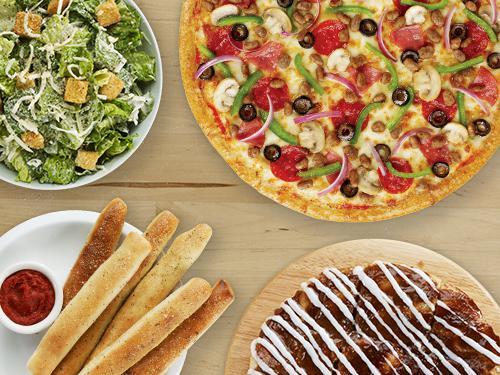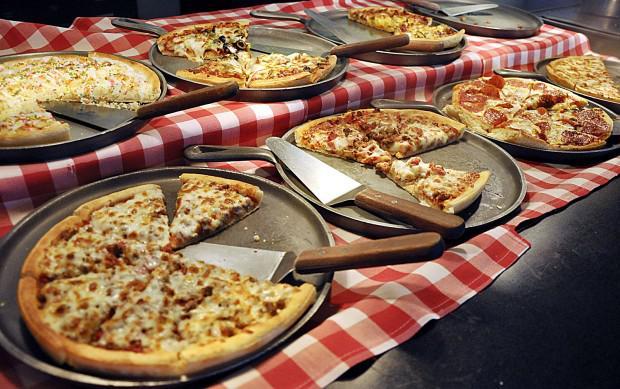The first image is the image on the left, the second image is the image on the right. Considering the images on both sides, is "There are no cut pizzas in the left image." valid? Answer yes or no. Yes. The first image is the image on the left, the second image is the image on the right. For the images displayed, is the sentence "People stand along a buffet in one of the images." factually correct? Answer yes or no. No. 